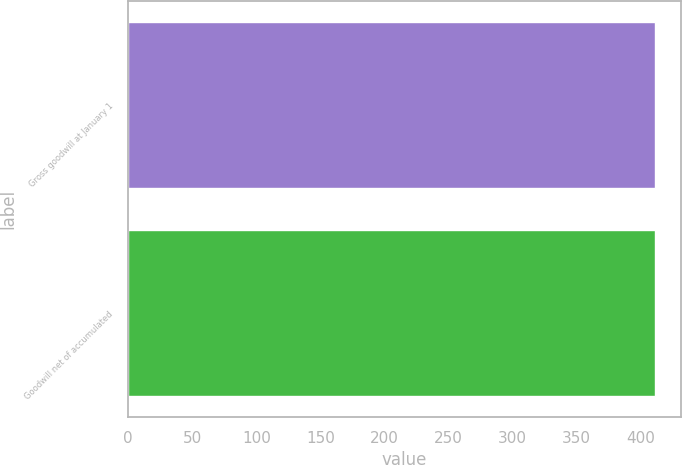<chart> <loc_0><loc_0><loc_500><loc_500><bar_chart><fcel>Gross goodwill at January 1<fcel>Goodwill net of accumulated<nl><fcel>411<fcel>411.1<nl></chart> 